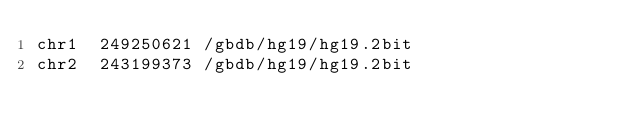<code> <loc_0><loc_0><loc_500><loc_500><_SQL_>chr1	249250621	/gbdb/hg19/hg19.2bit
chr2	243199373	/gbdb/hg19/hg19.2bit</code> 